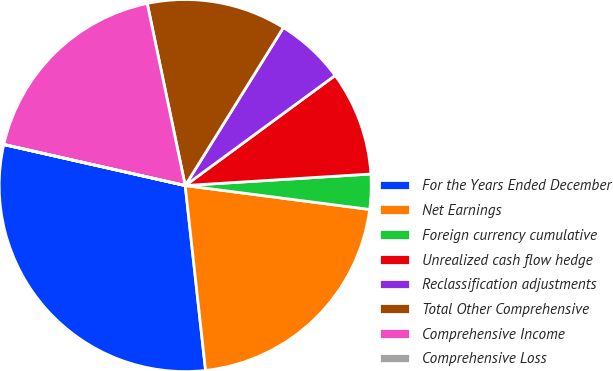<chart> <loc_0><loc_0><loc_500><loc_500><pie_chart><fcel>For the Years Ended December<fcel>Net Earnings<fcel>Foreign currency cumulative<fcel>Unrealized cash flow hedge<fcel>Reclassification adjustments<fcel>Total Other Comprehensive<fcel>Comprehensive Income<fcel>Comprehensive Loss<nl><fcel>30.28%<fcel>21.2%<fcel>3.04%<fcel>9.09%<fcel>6.07%<fcel>12.12%<fcel>18.18%<fcel>0.01%<nl></chart> 